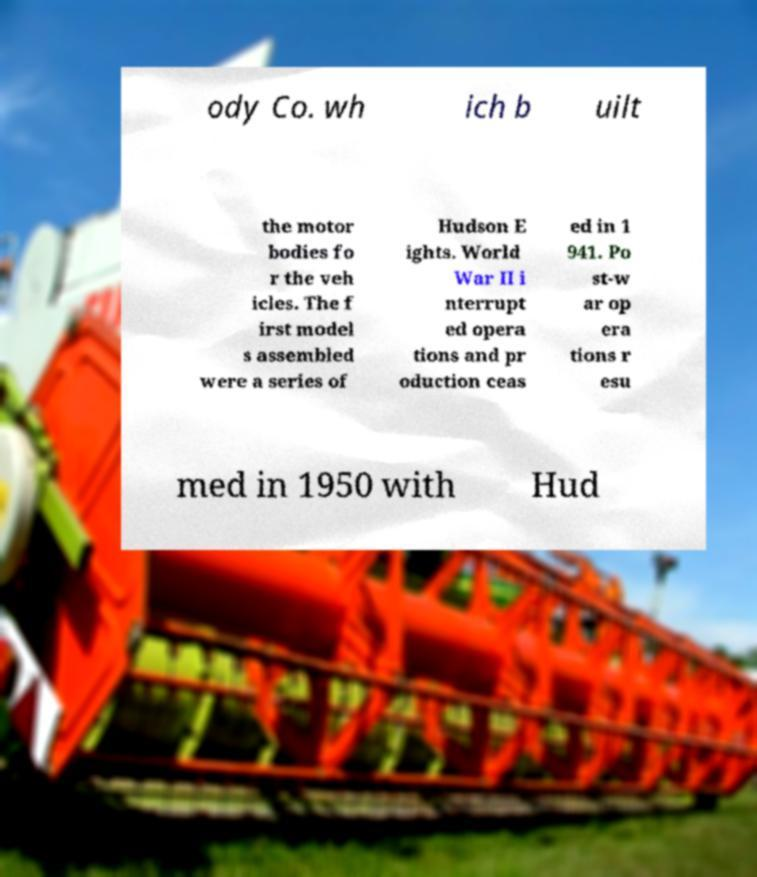Could you extract and type out the text from this image? ody Co. wh ich b uilt the motor bodies fo r the veh icles. The f irst model s assembled were a series of Hudson E ights. World War II i nterrupt ed opera tions and pr oduction ceas ed in 1 941. Po st-w ar op era tions r esu med in 1950 with Hud 